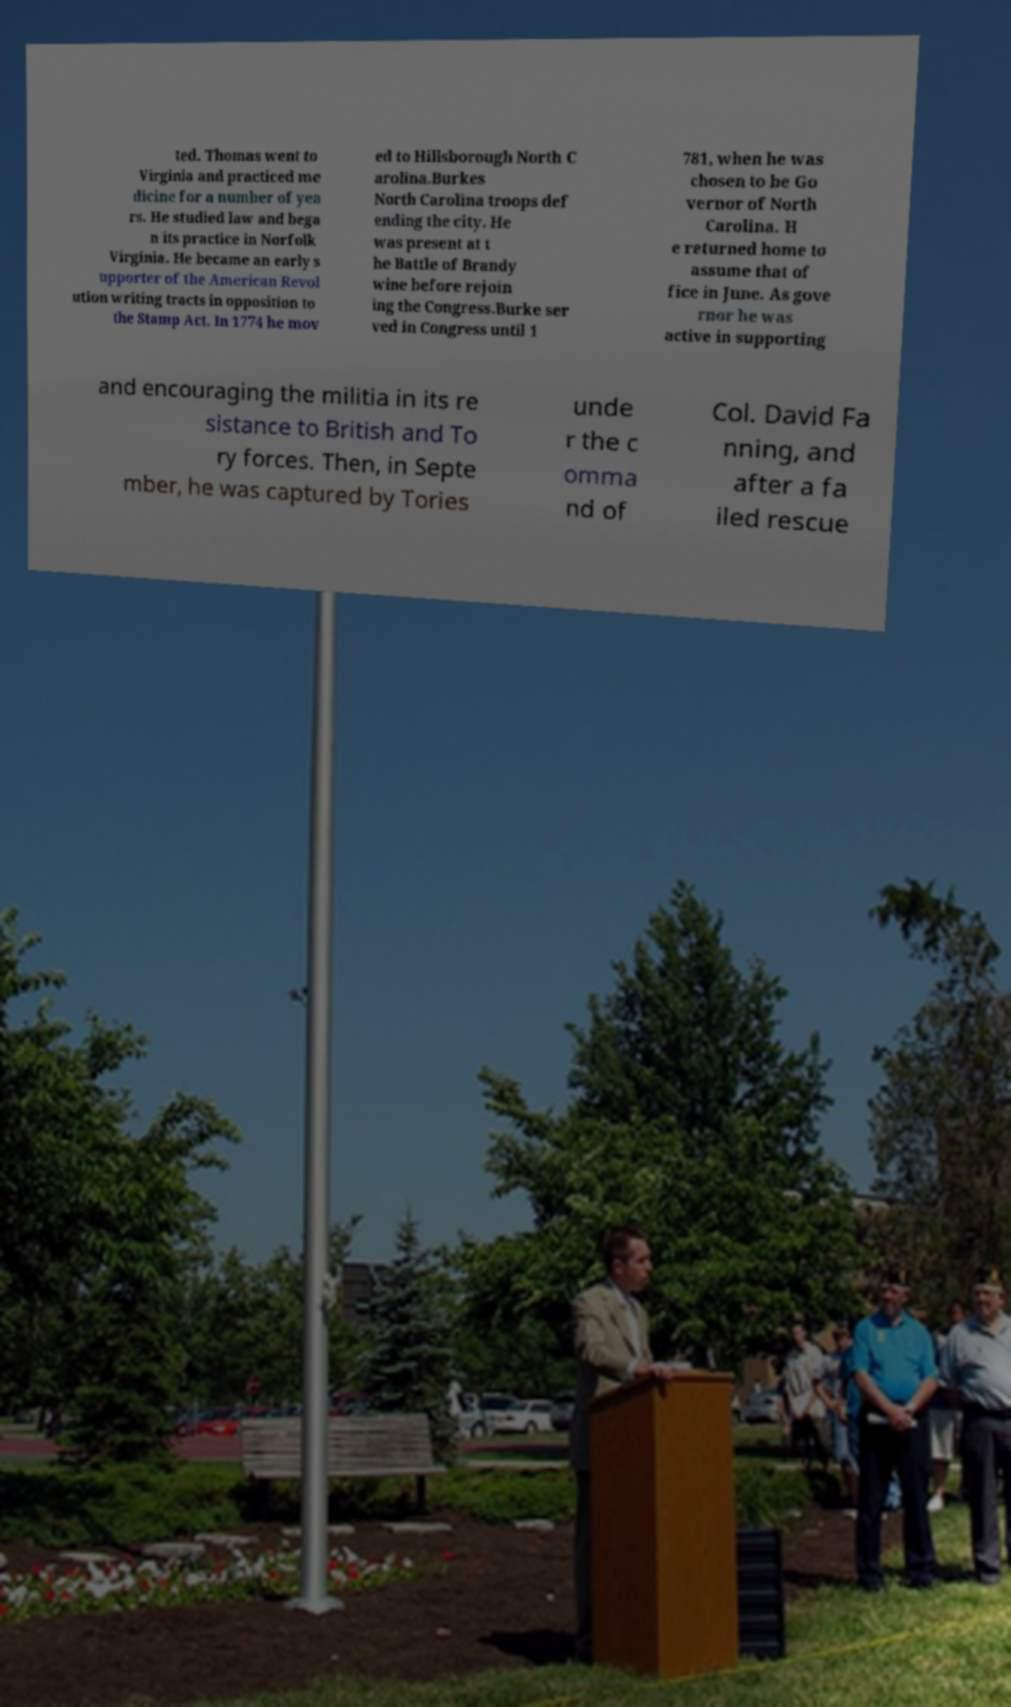I need the written content from this picture converted into text. Can you do that? ted. Thomas went to Virginia and practiced me dicine for a number of yea rs. He studied law and bega n its practice in Norfolk Virginia. He became an early s upporter of the American Revol ution writing tracts in opposition to the Stamp Act. In 1774 he mov ed to Hillsborough North C arolina.Burkes North Carolina troops def ending the city. He was present at t he Battle of Brandy wine before rejoin ing the Congress.Burke ser ved in Congress until 1 781, when he was chosen to be Go vernor of North Carolina. H e returned home to assume that of fice in June. As gove rnor he was active in supporting and encouraging the militia in its re sistance to British and To ry forces. Then, in Septe mber, he was captured by Tories unde r the c omma nd of Col. David Fa nning, and after a fa iled rescue 